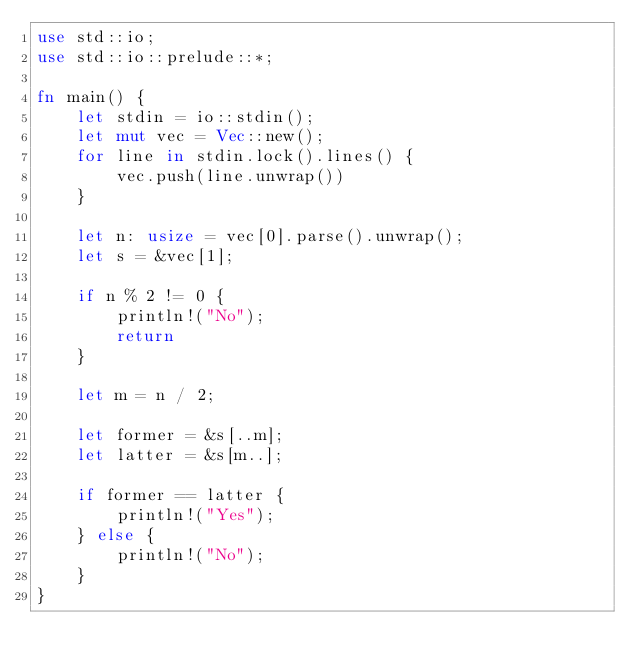<code> <loc_0><loc_0><loc_500><loc_500><_Rust_>use std::io;
use std::io::prelude::*;

fn main() {
    let stdin = io::stdin();
    let mut vec = Vec::new();
    for line in stdin.lock().lines() {
        vec.push(line.unwrap())
    }

    let n: usize = vec[0].parse().unwrap();
    let s = &vec[1];

    if n % 2 != 0 {
        println!("No");
        return
    }

    let m = n / 2;

    let former = &s[..m];
    let latter = &s[m..];
        
    if former == latter {
        println!("Yes");
    } else {
        println!("No");
    }
}
</code> 